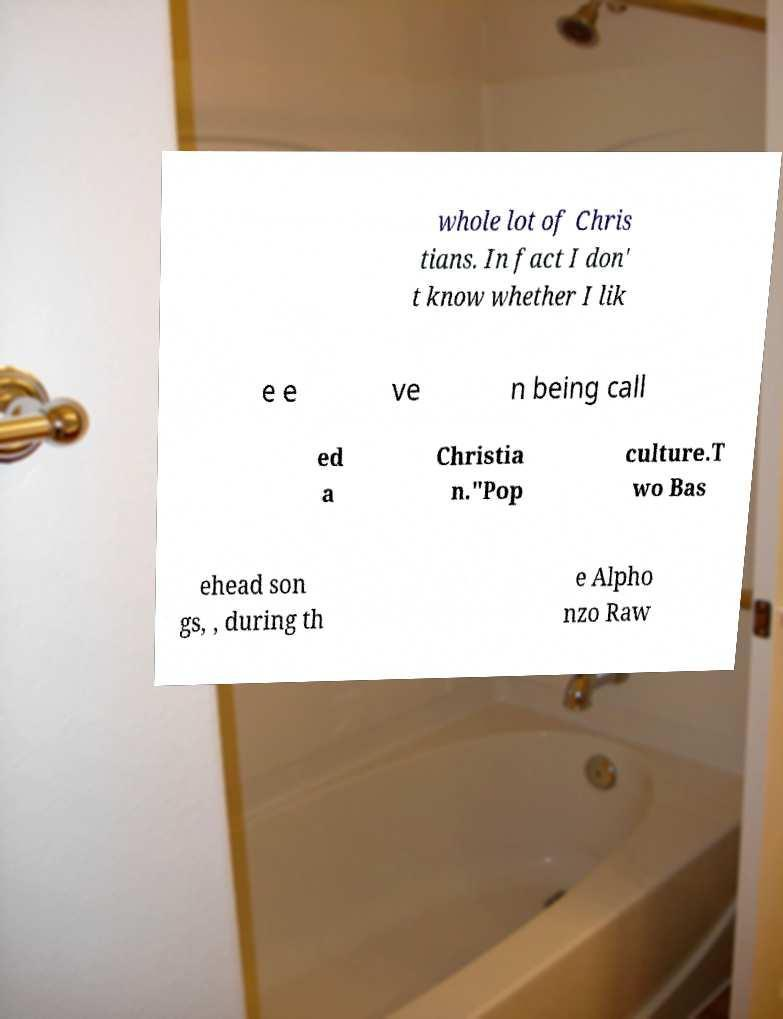What messages or text are displayed in this image? I need them in a readable, typed format. whole lot of Chris tians. In fact I don' t know whether I lik e e ve n being call ed a Christia n."Pop culture.T wo Bas ehead son gs, , during th e Alpho nzo Raw 